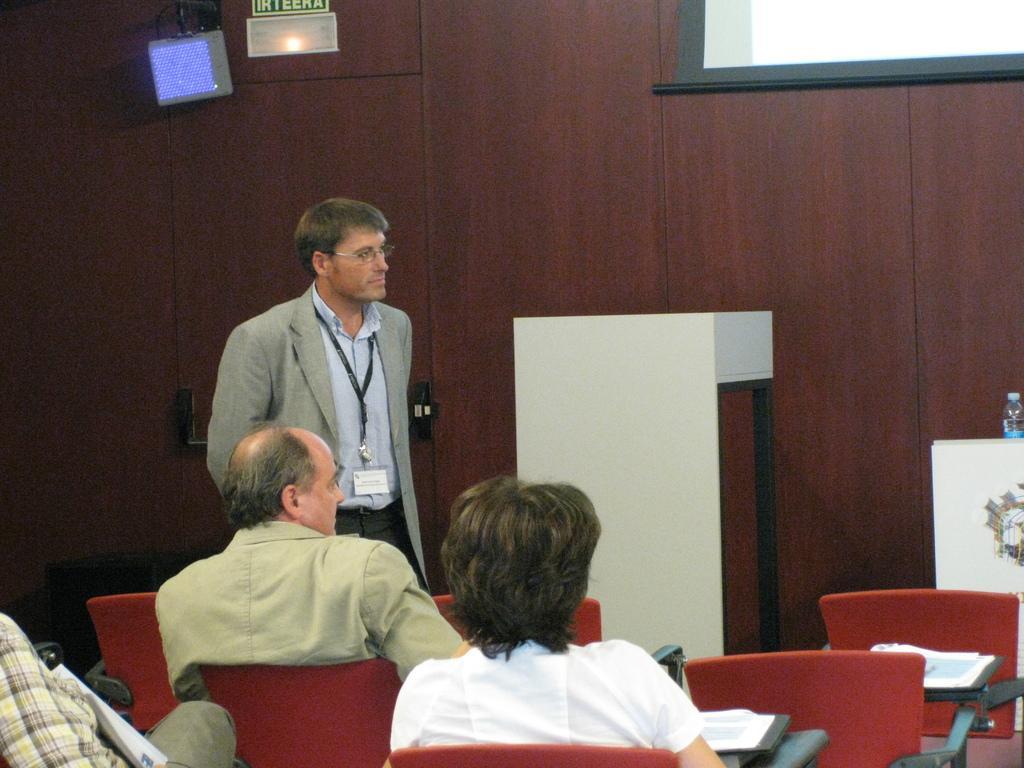Describe this image in one or two sentences. This is a picture taken in a room, there are a group of people sitting on chairs in front of these people a man is standing on the floor. Behind the man there is a podium and table on the table there is a bottle. Background of these people is a wall with projector screen, light and a sign board. 